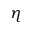<formula> <loc_0><loc_0><loc_500><loc_500>\eta</formula> 